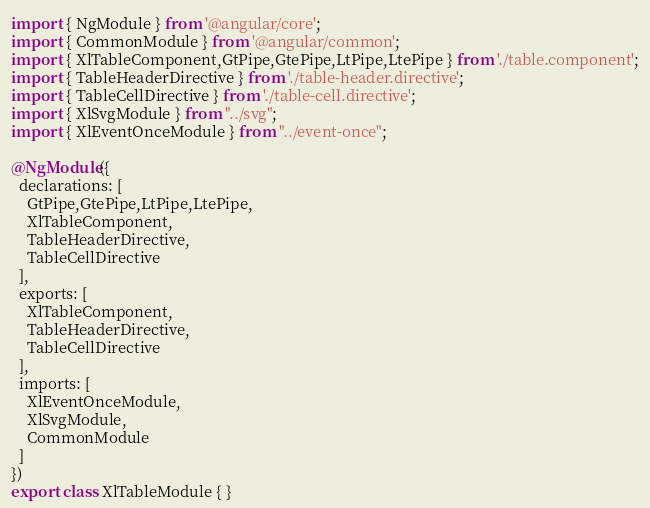Convert code to text. <code><loc_0><loc_0><loc_500><loc_500><_TypeScript_>import { NgModule } from '@angular/core';
import { CommonModule } from '@angular/common';
import { XlTableComponent,GtPipe,GtePipe,LtPipe,LtePipe } from './table.component';
import { TableHeaderDirective } from './table-header.directive';
import { TableCellDirective } from './table-cell.directive';
import { XlSvgModule } from "../svg";
import { XlEventOnceModule } from "../event-once";

@NgModule({
  declarations: [
    GtPipe,GtePipe,LtPipe,LtePipe,
    XlTableComponent,
    TableHeaderDirective,
    TableCellDirective
  ],
  exports: [
    XlTableComponent,
    TableHeaderDirective,
    TableCellDirective
  ],
  imports: [
    XlEventOnceModule,
    XlSvgModule,
    CommonModule
  ]
})
export class XlTableModule { }
</code> 